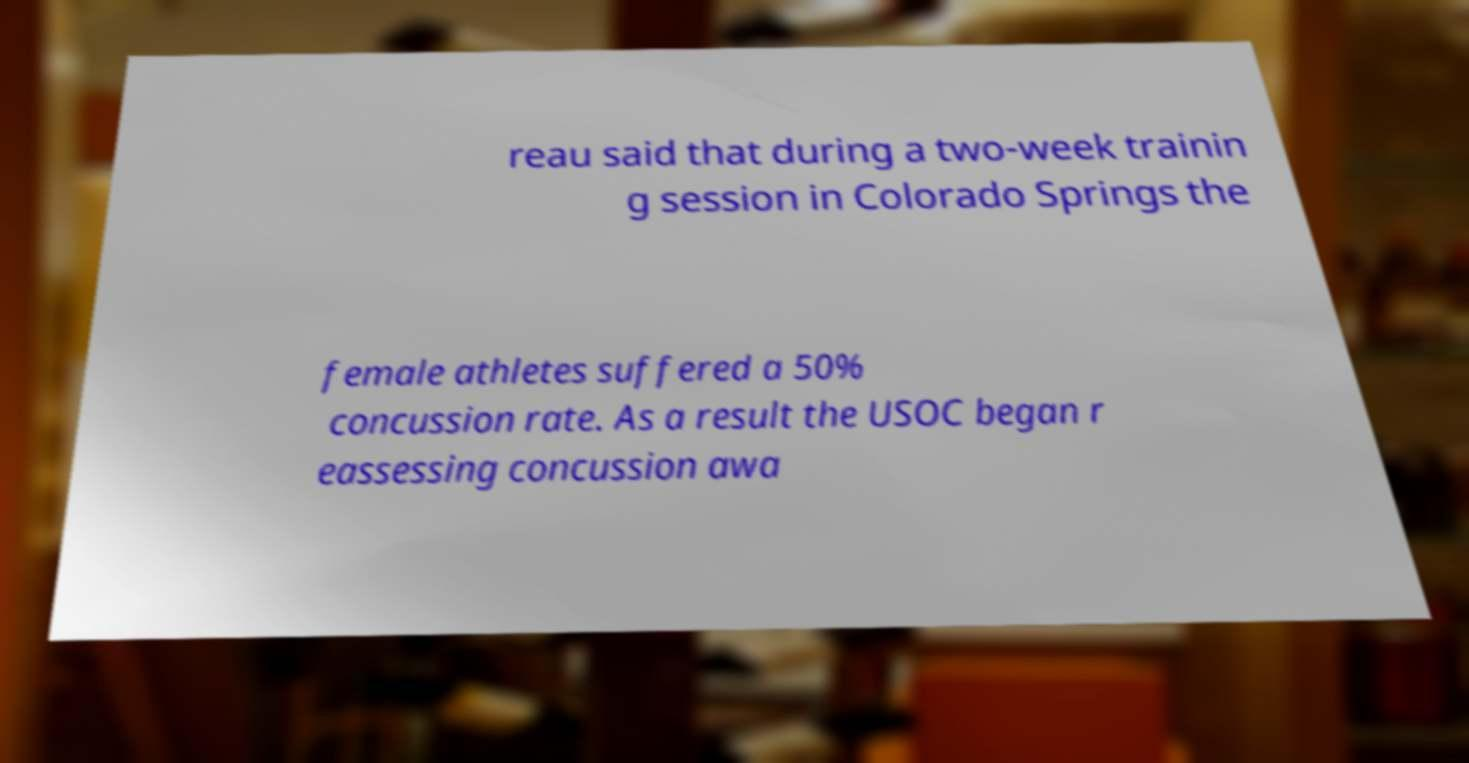Can you read and provide the text displayed in the image?This photo seems to have some interesting text. Can you extract and type it out for me? reau said that during a two-week trainin g session in Colorado Springs the female athletes suffered a 50% concussion rate. As a result the USOC began r eassessing concussion awa 